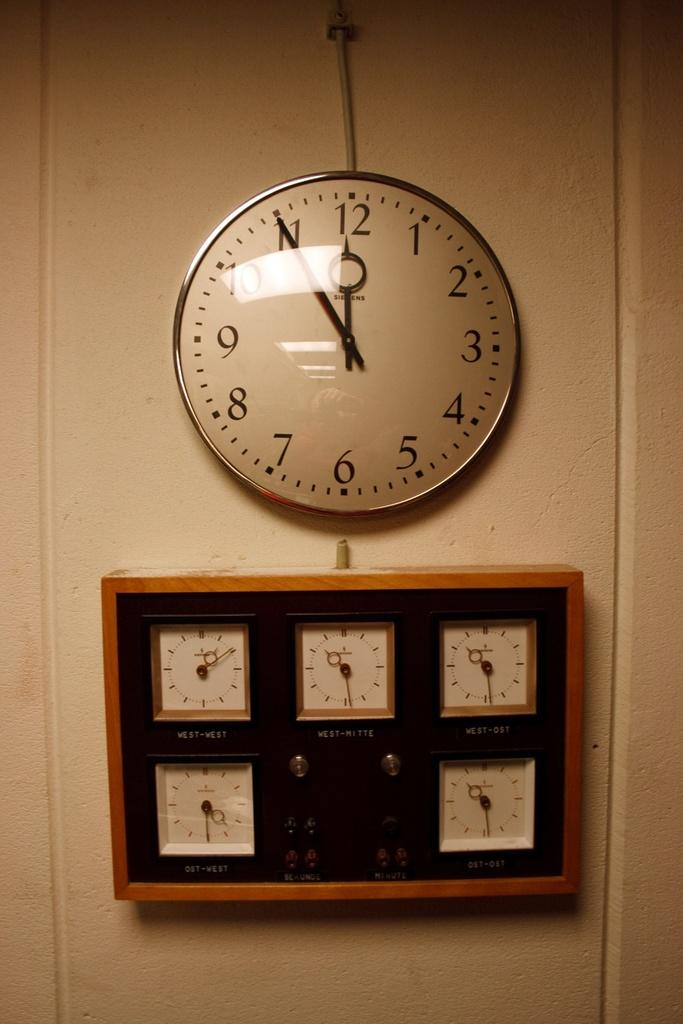<image>
Provide a brief description of the given image. wall clock with time at 5 til 12 and rectangular wooden clock below that has 5 small clocks within it 